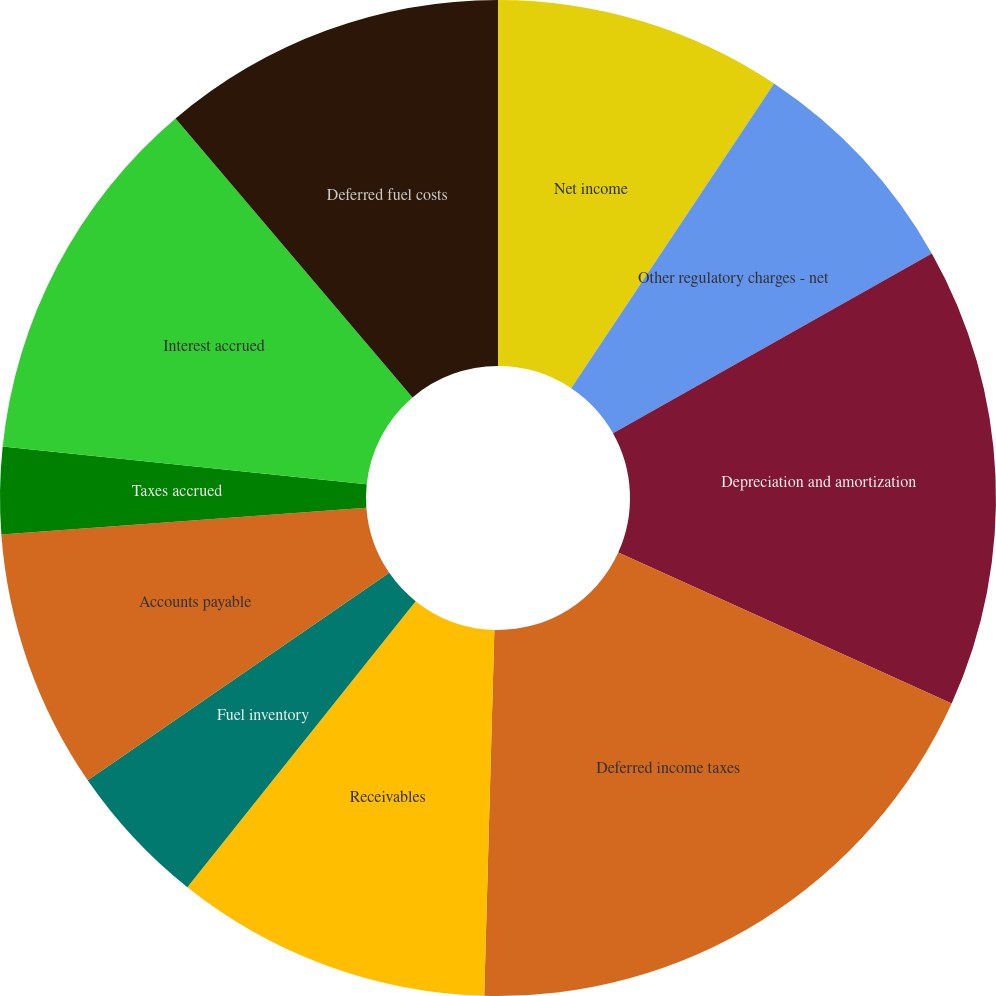Convert chart. <chart><loc_0><loc_0><loc_500><loc_500><pie_chart><fcel>Net income<fcel>Other regulatory charges - net<fcel>Depreciation and amortization<fcel>Deferred income taxes<fcel>Receivables<fcel>Fuel inventory<fcel>Accounts payable<fcel>Taxes accrued<fcel>Interest accrued<fcel>Deferred fuel costs<nl><fcel>9.35%<fcel>7.48%<fcel>14.94%<fcel>18.67%<fcel>10.28%<fcel>4.69%<fcel>8.42%<fcel>2.82%<fcel>12.14%<fcel>11.21%<nl></chart> 